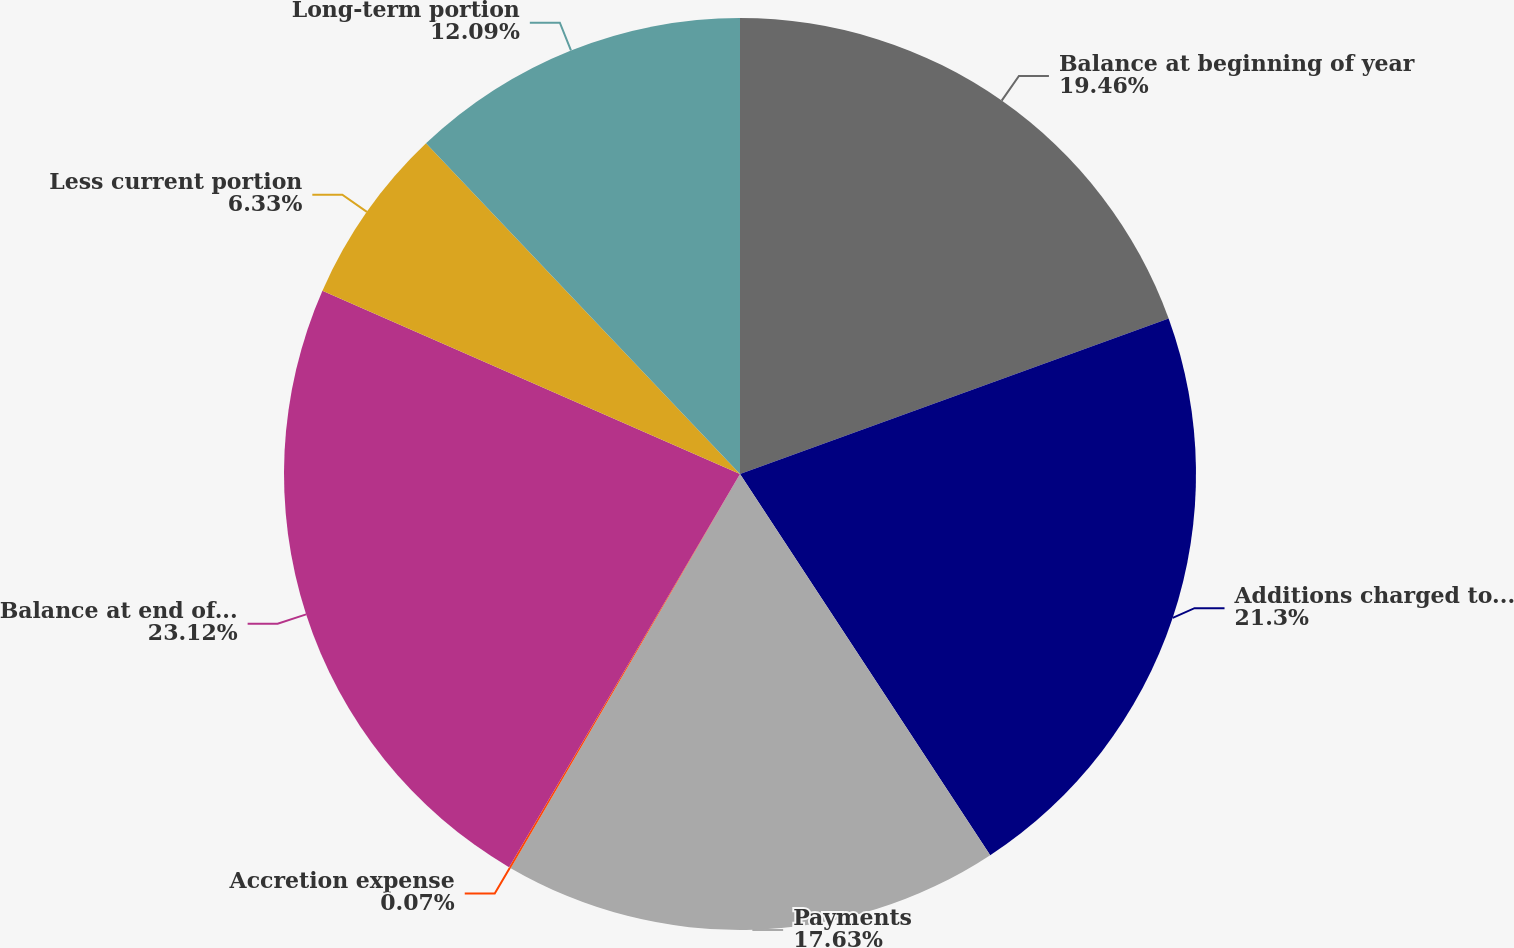Convert chart to OTSL. <chart><loc_0><loc_0><loc_500><loc_500><pie_chart><fcel>Balance at beginning of year<fcel>Additions charged to expense<fcel>Payments<fcel>Accretion expense<fcel>Balance at end of year<fcel>Less current portion<fcel>Long-term portion<nl><fcel>19.46%<fcel>21.3%<fcel>17.63%<fcel>0.07%<fcel>23.13%<fcel>6.33%<fcel>12.09%<nl></chart> 